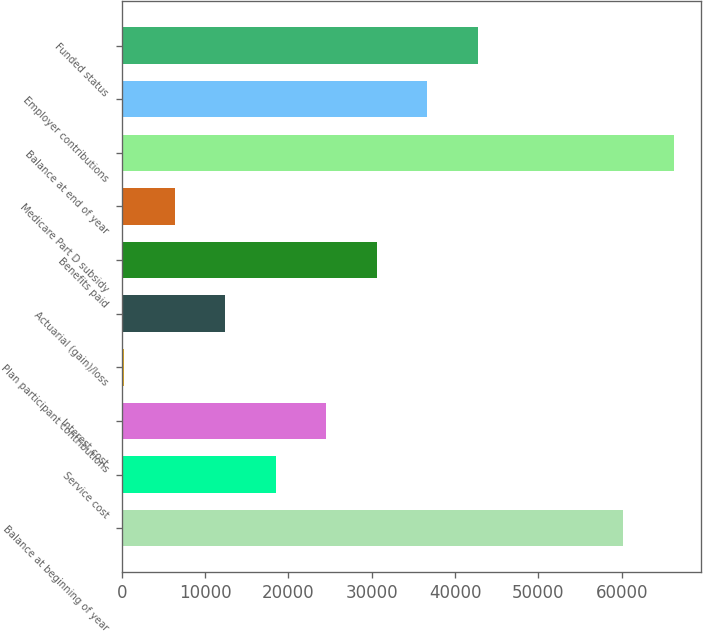Convert chart. <chart><loc_0><loc_0><loc_500><loc_500><bar_chart><fcel>Balance at beginning of year<fcel>Service cost<fcel>Interest cost<fcel>Plan participant contributions<fcel>Actuarial (gain)/loss<fcel>Benefits paid<fcel>Medicare Part D subsidy<fcel>Balance at end of year<fcel>Employer contributions<fcel>Funded status<nl><fcel>60193<fcel>18502.8<fcel>24566.4<fcel>312<fcel>12439.2<fcel>30630<fcel>6375.6<fcel>66256.6<fcel>36693.6<fcel>42757.2<nl></chart> 